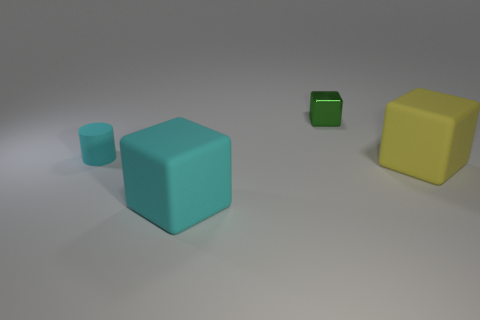Add 1 cyan matte things. How many objects exist? 5 Subtract all tiny green blocks. How many blocks are left? 2 Subtract all blocks. How many objects are left? 1 Subtract 1 cylinders. How many cylinders are left? 0 Add 4 small gray shiny balls. How many small gray shiny balls exist? 4 Subtract all green cubes. How many cubes are left? 2 Subtract 0 gray blocks. How many objects are left? 4 Subtract all purple cylinders. Subtract all yellow balls. How many cylinders are left? 1 Subtract all tiny cyan rubber things. Subtract all cyan objects. How many objects are left? 1 Add 1 tiny rubber things. How many tiny rubber things are left? 2 